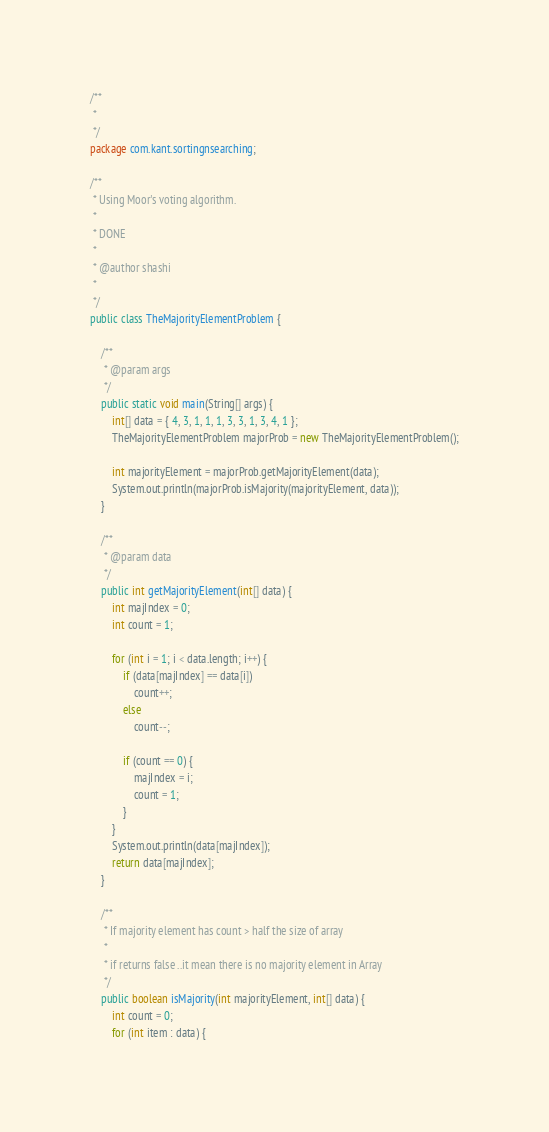<code> <loc_0><loc_0><loc_500><loc_500><_Java_>/**
 * 
 */
package com.kant.sortingnsearching;

/**
 * Using Moor's voting algorithm.
 * 
 * DONE
 * 
 * @author shashi
 * 
 */
public class TheMajorityElementProblem {

	/**
	 * @param args
	 */
	public static void main(String[] args) {
		int[] data = { 4, 3, 1, 1, 1, 3, 3, 1, 3, 4, 1 };
		TheMajorityElementProblem majorProb = new TheMajorityElementProblem();

		int majorityElement = majorProb.getMajorityElement(data);
		System.out.println(majorProb.isMajority(majorityElement, data));
	}

	/**
	 * @param data
	 */
	public int getMajorityElement(int[] data) {
		int majIndex = 0;
		int count = 1;

		for (int i = 1; i < data.length; i++) {
			if (data[majIndex] == data[i])
				count++;
			else
				count--;

			if (count == 0) {
				majIndex = i;
				count = 1;
			}
		}
		System.out.println(data[majIndex]);
		return data[majIndex];
	}

	/**
	 * If majority element has count > half the size of array
	 * 
	 * if returns false ..it mean there is no majority element in Array
	 */
	public boolean isMajority(int majorityElement, int[] data) {
		int count = 0;
		for (int item : data) {</code> 